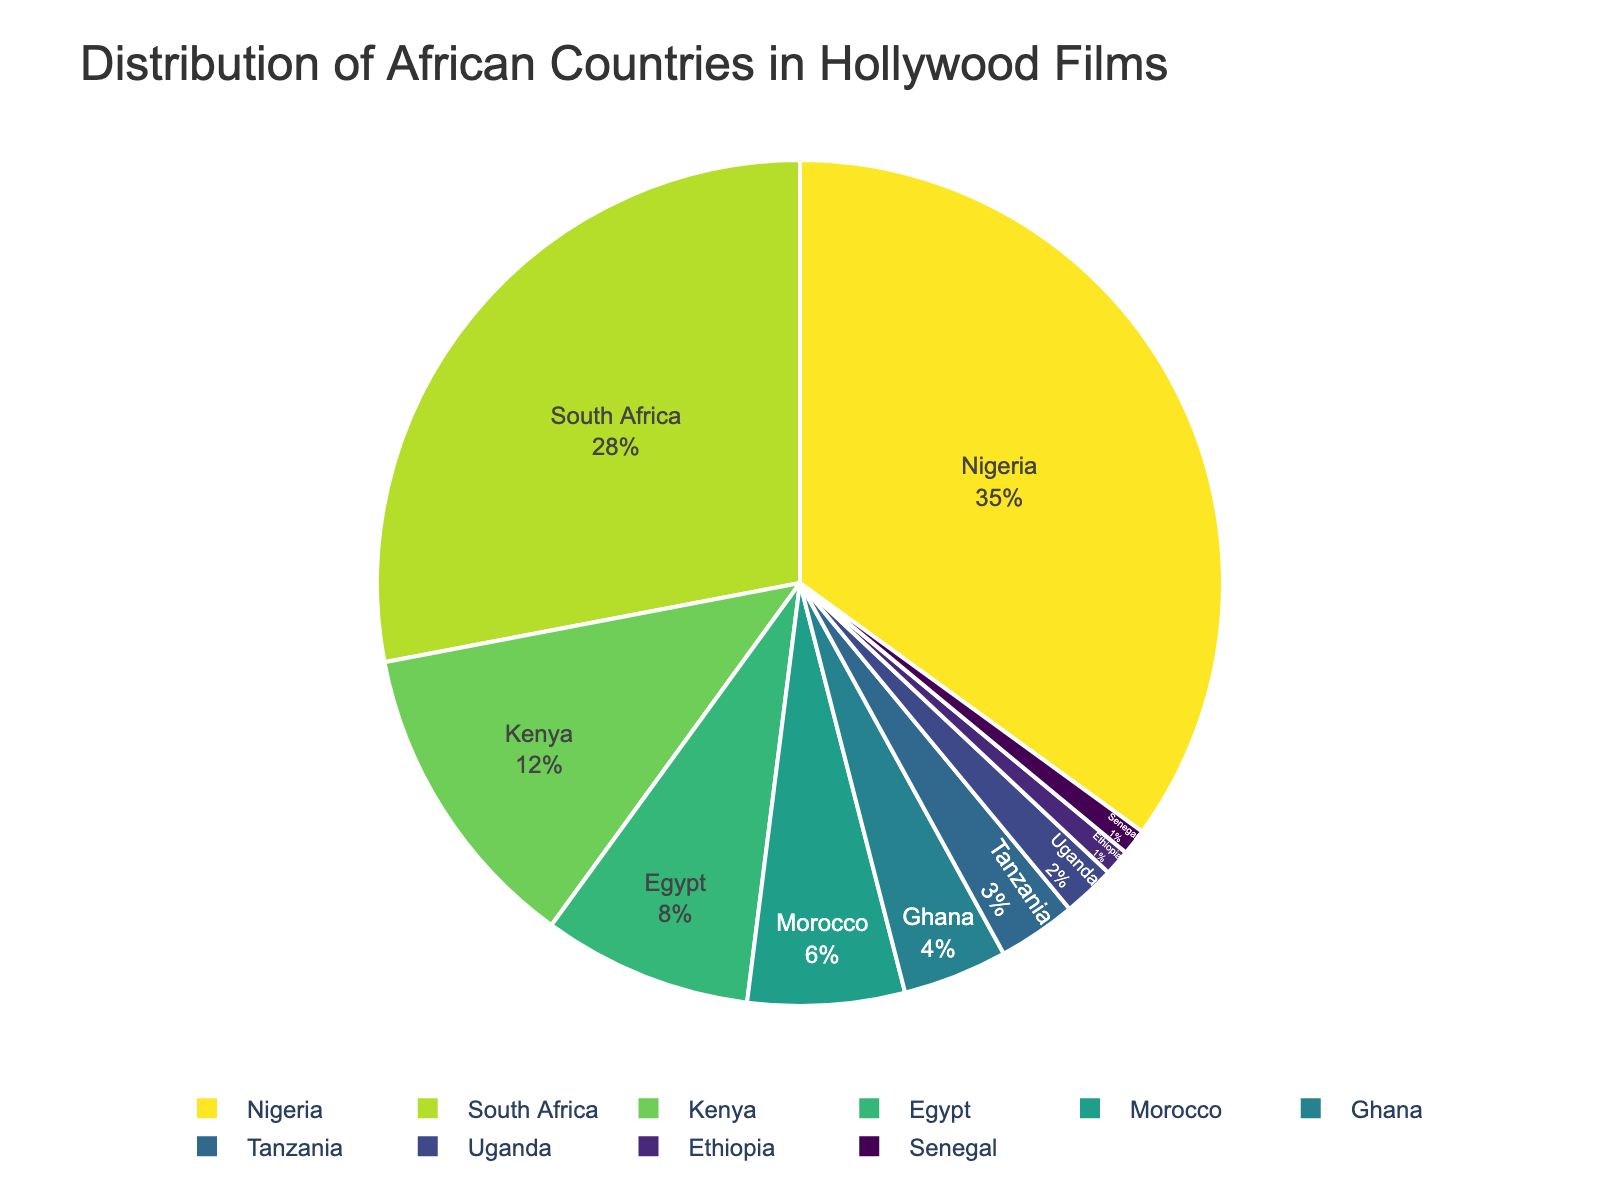Which African country is most represented in Hollywood films? By checking the pie chart, the country with the largest percentage slice is the most represented. Nigeria has the largest slice at 35%.
Answer: Nigeria Which three countries have the least representation in Hollywood films? By observing the smallest slices in the pie chart, Ethiopia, Senegal, and Uganda have the least representation with 1%, 1%, and 2% respectively.
Answer: Ethiopia, Senegal, Uganda What is the total representation percentage of Nigeria, South Africa, and Kenya combined? Add the percentages of Nigeria (35%), South Africa (28%), and Kenya (12%). 35 + 28 + 12 = 75%.
Answer: 75% Is Ghana more represented than Morocco? Compare the slices of Ghana and Morocco in the pie chart. Ghana has 4%, whereas Morocco has 6%.
Answer: No By what percentage is South Africa more represented than Egypt? Subtract the percentage of Egypt (8%) from South Africa (28%). 28 - 8 = 20%.
Answer: 20% What percentage of representation do countries other than Nigeria have? Subtract the percentage of Nigeria (35%) from 100%. 100 - 35 = 65%.
Answer: 65% If you combine the representation percentages of Tanzania, Uganda, and Ethiopia, how does it compare to Kenya's representation? Add the percentages of Tanzania (3%), Uganda (2%), and Ethiopia (1%) to get 3 + 2 + 1 = 6%. Compare this sum with Kenya's 12%. 6% is less than 12%.
Answer: Less Which color is associated with South Africa in the pie chart? Identify the color used for South Africa in the visual representation. This information is unique to the pie chart and colors designed by the visualization.
Answer: (example: blue, but this must be inferred from the actual visual) What would you expect the average representation percentage to be if it were evenly distributed among all listed countries? Divide 100% by the number of countries (10). 100 / 10 = 10%.
Answer: 10% What is the difference in representation between the most and least represented countries? Subtract the percentage of the least represented country (1%, either Senegal or Ethiopia) from the percentage of the most represented country (35%, Nigeria). 35 - 1 = 34%.
Answer: 34% 